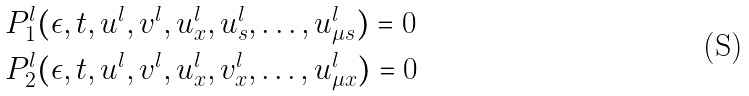Convert formula to latex. <formula><loc_0><loc_0><loc_500><loc_500>& P _ { 1 } ^ { l } ( \epsilon , t , u ^ { l } , v ^ { l } , u _ { x } ^ { l } , u _ { s } ^ { l } , \dots , u _ { \mu s } ^ { l } ) = 0 \\ & P _ { 2 } ^ { l } ( \epsilon , t , u ^ { l } , v ^ { l } , u _ { x } ^ { l } , v _ { x } ^ { l } , \dots , u _ { \mu x } ^ { l } ) = 0</formula> 